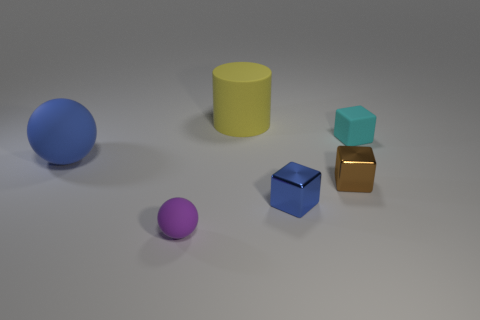Add 2 large blue things. How many objects exist? 8 Subtract all spheres. How many objects are left? 4 Subtract all tiny gray matte cylinders. Subtract all yellow matte things. How many objects are left? 5 Add 5 big matte spheres. How many big matte spheres are left? 6 Add 5 small cyan rubber things. How many small cyan rubber things exist? 6 Subtract 0 red spheres. How many objects are left? 6 